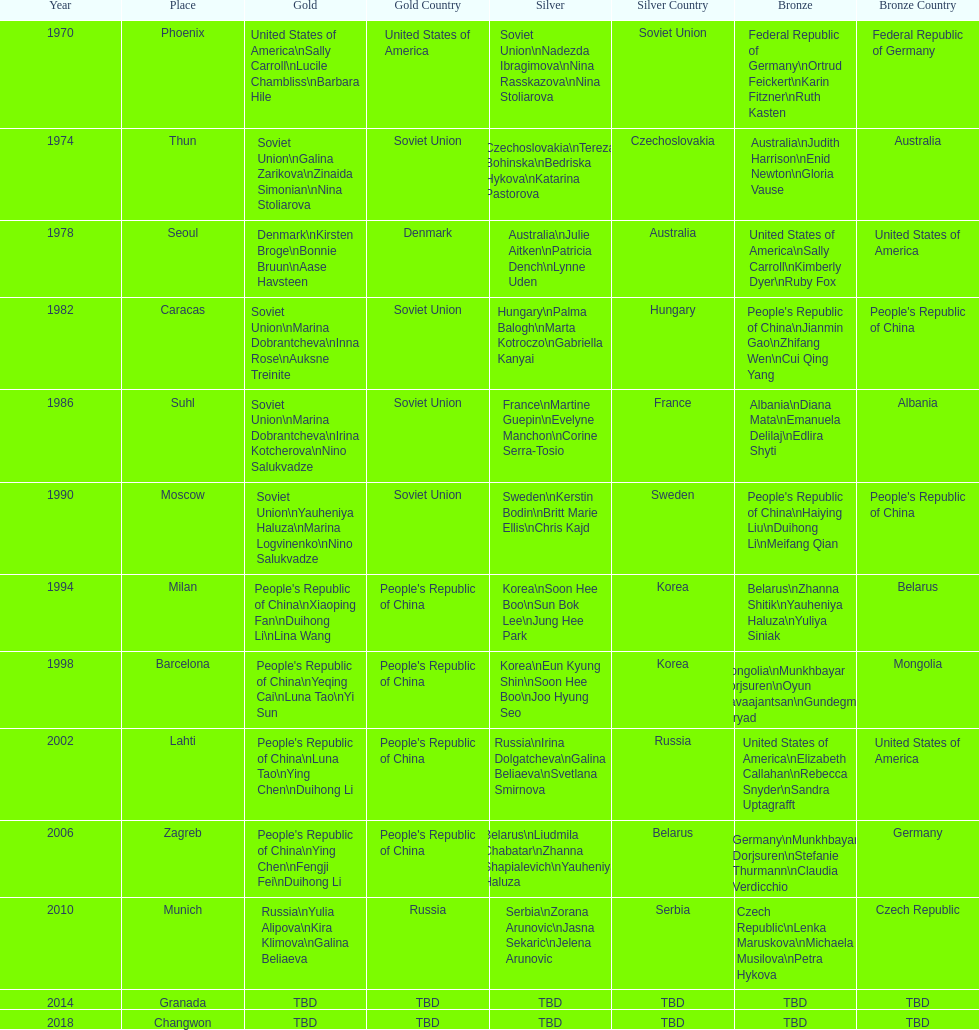What are the total number of times the soviet union is listed under the gold column? 4. 